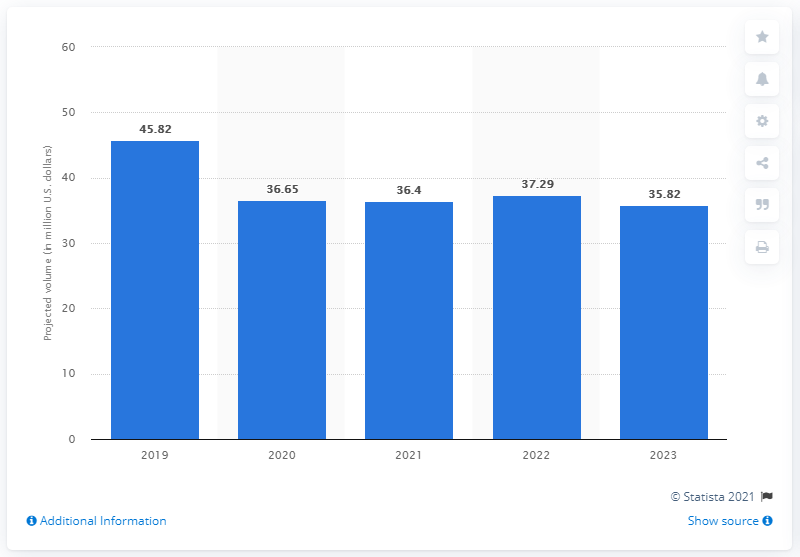Draw attention to some important aspects in this diagram. The projected volume of defined benefit pension plans for Mattel by 2023 is 35.82. 